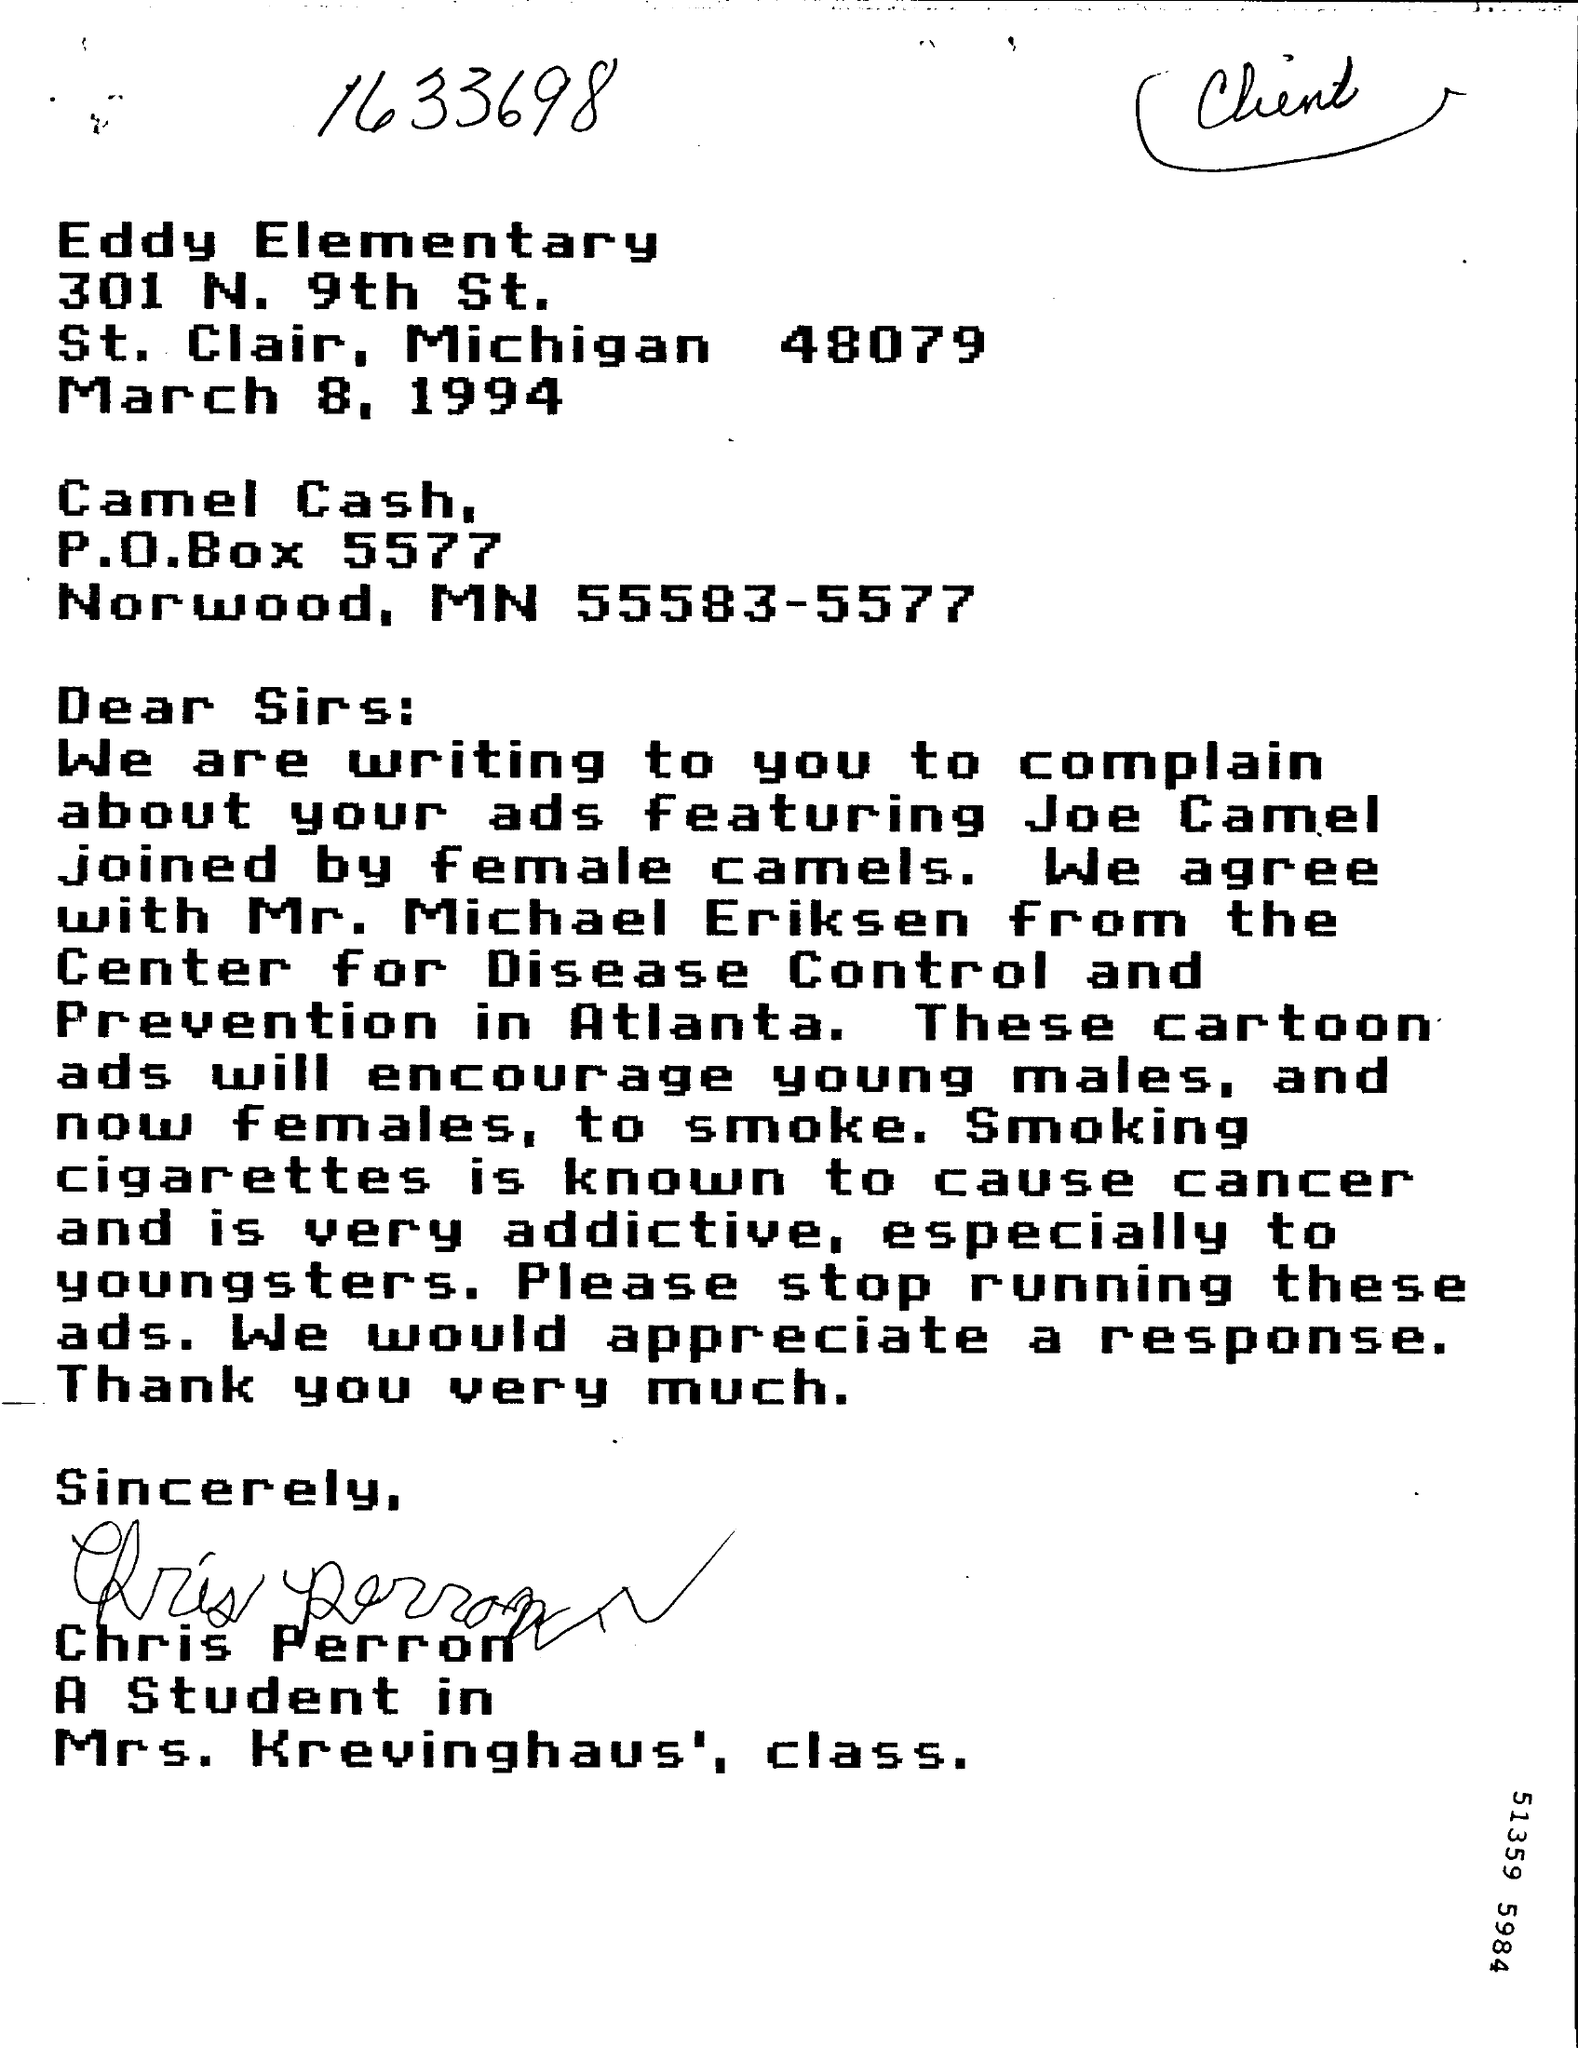Give some essential details in this illustration. The P.O.Box number is P.O.Box 5577. 